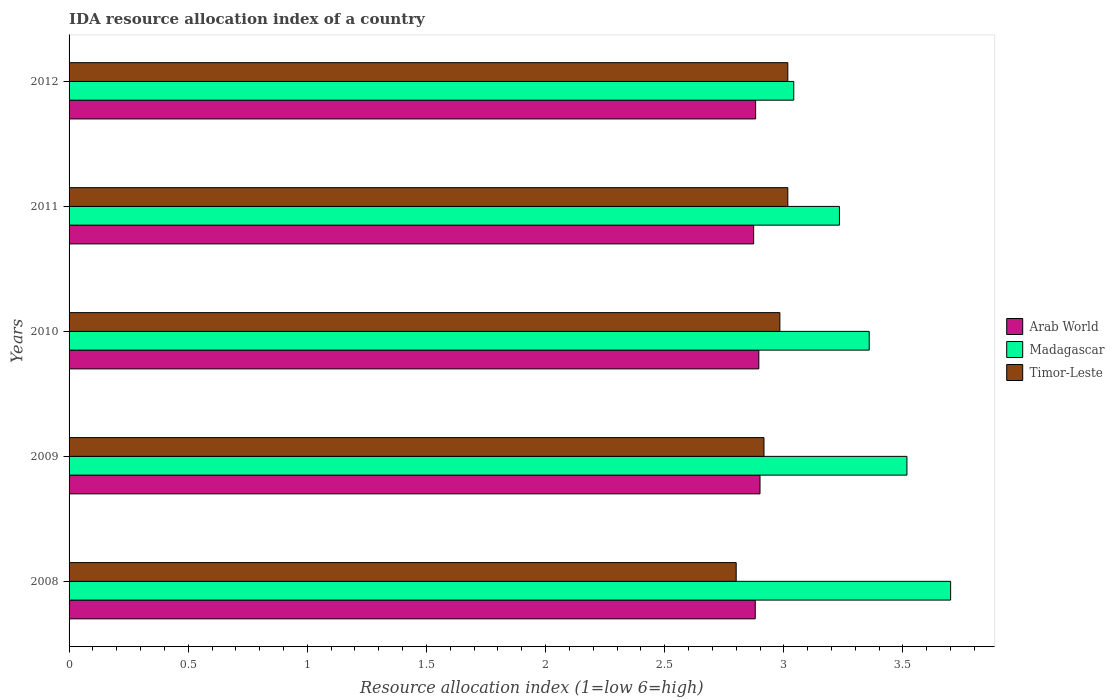Are the number of bars per tick equal to the number of legend labels?
Ensure brevity in your answer.  Yes. How many bars are there on the 3rd tick from the bottom?
Your response must be concise. 3. What is the label of the 1st group of bars from the top?
Keep it short and to the point. 2012. In how many cases, is the number of bars for a given year not equal to the number of legend labels?
Your answer should be compact. 0. What is the IDA resource allocation index in Madagascar in 2008?
Your answer should be very brief. 3.7. Across all years, what is the maximum IDA resource allocation index in Timor-Leste?
Your response must be concise. 3.02. Across all years, what is the minimum IDA resource allocation index in Madagascar?
Offer a terse response. 3.04. In which year was the IDA resource allocation index in Arab World maximum?
Provide a short and direct response. 2009. What is the total IDA resource allocation index in Arab World in the graph?
Make the answer very short. 14.43. What is the difference between the IDA resource allocation index in Arab World in 2009 and that in 2010?
Give a very brief answer. 0. What is the difference between the IDA resource allocation index in Arab World in 2011 and the IDA resource allocation index in Timor-Leste in 2012?
Provide a short and direct response. -0.14. What is the average IDA resource allocation index in Arab World per year?
Your answer should be very brief. 2.89. In the year 2008, what is the difference between the IDA resource allocation index in Timor-Leste and IDA resource allocation index in Madagascar?
Offer a very short reply. -0.9. What is the ratio of the IDA resource allocation index in Madagascar in 2009 to that in 2011?
Make the answer very short. 1.09. Is the IDA resource allocation index in Madagascar in 2008 less than that in 2010?
Your answer should be compact. No. Is the difference between the IDA resource allocation index in Timor-Leste in 2010 and 2012 greater than the difference between the IDA resource allocation index in Madagascar in 2010 and 2012?
Provide a short and direct response. No. What is the difference between the highest and the second highest IDA resource allocation index in Madagascar?
Make the answer very short. 0.18. What is the difference between the highest and the lowest IDA resource allocation index in Madagascar?
Provide a short and direct response. 0.66. In how many years, is the IDA resource allocation index in Timor-Leste greater than the average IDA resource allocation index in Timor-Leste taken over all years?
Provide a short and direct response. 3. What does the 2nd bar from the top in 2009 represents?
Your response must be concise. Madagascar. What does the 3rd bar from the bottom in 2008 represents?
Your response must be concise. Timor-Leste. Is it the case that in every year, the sum of the IDA resource allocation index in Arab World and IDA resource allocation index in Timor-Leste is greater than the IDA resource allocation index in Madagascar?
Provide a succinct answer. Yes. How many years are there in the graph?
Your answer should be very brief. 5. Does the graph contain any zero values?
Your answer should be very brief. No. Does the graph contain grids?
Your answer should be very brief. No. Where does the legend appear in the graph?
Provide a short and direct response. Center right. How many legend labels are there?
Give a very brief answer. 3. What is the title of the graph?
Offer a very short reply. IDA resource allocation index of a country. What is the label or title of the X-axis?
Offer a terse response. Resource allocation index (1=low 6=high). What is the label or title of the Y-axis?
Your answer should be very brief. Years. What is the Resource allocation index (1=low 6=high) in Arab World in 2008?
Make the answer very short. 2.88. What is the Resource allocation index (1=low 6=high) in Timor-Leste in 2008?
Your answer should be compact. 2.8. What is the Resource allocation index (1=low 6=high) in Madagascar in 2009?
Offer a very short reply. 3.52. What is the Resource allocation index (1=low 6=high) of Timor-Leste in 2009?
Offer a terse response. 2.92. What is the Resource allocation index (1=low 6=high) of Arab World in 2010?
Your response must be concise. 2.9. What is the Resource allocation index (1=low 6=high) of Madagascar in 2010?
Make the answer very short. 3.36. What is the Resource allocation index (1=low 6=high) in Timor-Leste in 2010?
Your answer should be compact. 2.98. What is the Resource allocation index (1=low 6=high) in Arab World in 2011?
Your answer should be compact. 2.87. What is the Resource allocation index (1=low 6=high) of Madagascar in 2011?
Your response must be concise. 3.23. What is the Resource allocation index (1=low 6=high) of Timor-Leste in 2011?
Make the answer very short. 3.02. What is the Resource allocation index (1=low 6=high) of Arab World in 2012?
Your response must be concise. 2.88. What is the Resource allocation index (1=low 6=high) of Madagascar in 2012?
Ensure brevity in your answer.  3.04. What is the Resource allocation index (1=low 6=high) of Timor-Leste in 2012?
Provide a succinct answer. 3.02. Across all years, what is the maximum Resource allocation index (1=low 6=high) of Madagascar?
Your answer should be very brief. 3.7. Across all years, what is the maximum Resource allocation index (1=low 6=high) in Timor-Leste?
Ensure brevity in your answer.  3.02. Across all years, what is the minimum Resource allocation index (1=low 6=high) in Arab World?
Offer a terse response. 2.87. Across all years, what is the minimum Resource allocation index (1=low 6=high) of Madagascar?
Offer a terse response. 3.04. What is the total Resource allocation index (1=low 6=high) in Arab World in the graph?
Offer a terse response. 14.43. What is the total Resource allocation index (1=low 6=high) of Madagascar in the graph?
Offer a very short reply. 16.85. What is the total Resource allocation index (1=low 6=high) in Timor-Leste in the graph?
Make the answer very short. 14.73. What is the difference between the Resource allocation index (1=low 6=high) in Arab World in 2008 and that in 2009?
Your response must be concise. -0.02. What is the difference between the Resource allocation index (1=low 6=high) of Madagascar in 2008 and that in 2009?
Your answer should be compact. 0.18. What is the difference between the Resource allocation index (1=low 6=high) of Timor-Leste in 2008 and that in 2009?
Offer a very short reply. -0.12. What is the difference between the Resource allocation index (1=low 6=high) of Arab World in 2008 and that in 2010?
Your response must be concise. -0.01. What is the difference between the Resource allocation index (1=low 6=high) in Madagascar in 2008 and that in 2010?
Your answer should be very brief. 0.34. What is the difference between the Resource allocation index (1=low 6=high) in Timor-Leste in 2008 and that in 2010?
Provide a succinct answer. -0.18. What is the difference between the Resource allocation index (1=low 6=high) in Arab World in 2008 and that in 2011?
Make the answer very short. 0.01. What is the difference between the Resource allocation index (1=low 6=high) in Madagascar in 2008 and that in 2011?
Provide a succinct answer. 0.47. What is the difference between the Resource allocation index (1=low 6=high) in Timor-Leste in 2008 and that in 2011?
Offer a terse response. -0.22. What is the difference between the Resource allocation index (1=low 6=high) of Arab World in 2008 and that in 2012?
Ensure brevity in your answer.  -0. What is the difference between the Resource allocation index (1=low 6=high) in Madagascar in 2008 and that in 2012?
Your answer should be very brief. 0.66. What is the difference between the Resource allocation index (1=low 6=high) of Timor-Leste in 2008 and that in 2012?
Provide a short and direct response. -0.22. What is the difference between the Resource allocation index (1=low 6=high) in Arab World in 2009 and that in 2010?
Make the answer very short. 0.01. What is the difference between the Resource allocation index (1=low 6=high) in Madagascar in 2009 and that in 2010?
Your response must be concise. 0.16. What is the difference between the Resource allocation index (1=low 6=high) of Timor-Leste in 2009 and that in 2010?
Keep it short and to the point. -0.07. What is the difference between the Resource allocation index (1=low 6=high) of Arab World in 2009 and that in 2011?
Provide a succinct answer. 0.03. What is the difference between the Resource allocation index (1=low 6=high) in Madagascar in 2009 and that in 2011?
Your answer should be very brief. 0.28. What is the difference between the Resource allocation index (1=low 6=high) of Arab World in 2009 and that in 2012?
Your response must be concise. 0.02. What is the difference between the Resource allocation index (1=low 6=high) in Madagascar in 2009 and that in 2012?
Your answer should be compact. 0.47. What is the difference between the Resource allocation index (1=low 6=high) of Timor-Leste in 2009 and that in 2012?
Your answer should be very brief. -0.1. What is the difference between the Resource allocation index (1=low 6=high) in Arab World in 2010 and that in 2011?
Offer a terse response. 0.02. What is the difference between the Resource allocation index (1=low 6=high) of Madagascar in 2010 and that in 2011?
Ensure brevity in your answer.  0.12. What is the difference between the Resource allocation index (1=low 6=high) of Timor-Leste in 2010 and that in 2011?
Ensure brevity in your answer.  -0.03. What is the difference between the Resource allocation index (1=low 6=high) in Arab World in 2010 and that in 2012?
Your response must be concise. 0.01. What is the difference between the Resource allocation index (1=low 6=high) in Madagascar in 2010 and that in 2012?
Keep it short and to the point. 0.32. What is the difference between the Resource allocation index (1=low 6=high) in Timor-Leste in 2010 and that in 2012?
Ensure brevity in your answer.  -0.03. What is the difference between the Resource allocation index (1=low 6=high) in Arab World in 2011 and that in 2012?
Your answer should be compact. -0.01. What is the difference between the Resource allocation index (1=low 6=high) in Madagascar in 2011 and that in 2012?
Provide a short and direct response. 0.19. What is the difference between the Resource allocation index (1=low 6=high) in Timor-Leste in 2011 and that in 2012?
Offer a terse response. 0. What is the difference between the Resource allocation index (1=low 6=high) of Arab World in 2008 and the Resource allocation index (1=low 6=high) of Madagascar in 2009?
Make the answer very short. -0.64. What is the difference between the Resource allocation index (1=low 6=high) of Arab World in 2008 and the Resource allocation index (1=low 6=high) of Timor-Leste in 2009?
Your response must be concise. -0.04. What is the difference between the Resource allocation index (1=low 6=high) in Madagascar in 2008 and the Resource allocation index (1=low 6=high) in Timor-Leste in 2009?
Ensure brevity in your answer.  0.78. What is the difference between the Resource allocation index (1=low 6=high) of Arab World in 2008 and the Resource allocation index (1=low 6=high) of Madagascar in 2010?
Provide a succinct answer. -0.48. What is the difference between the Resource allocation index (1=low 6=high) of Arab World in 2008 and the Resource allocation index (1=low 6=high) of Timor-Leste in 2010?
Provide a succinct answer. -0.1. What is the difference between the Resource allocation index (1=low 6=high) in Madagascar in 2008 and the Resource allocation index (1=low 6=high) in Timor-Leste in 2010?
Offer a terse response. 0.72. What is the difference between the Resource allocation index (1=low 6=high) of Arab World in 2008 and the Resource allocation index (1=low 6=high) of Madagascar in 2011?
Your response must be concise. -0.35. What is the difference between the Resource allocation index (1=low 6=high) of Arab World in 2008 and the Resource allocation index (1=low 6=high) of Timor-Leste in 2011?
Make the answer very short. -0.14. What is the difference between the Resource allocation index (1=low 6=high) of Madagascar in 2008 and the Resource allocation index (1=low 6=high) of Timor-Leste in 2011?
Provide a succinct answer. 0.68. What is the difference between the Resource allocation index (1=low 6=high) in Arab World in 2008 and the Resource allocation index (1=low 6=high) in Madagascar in 2012?
Offer a terse response. -0.16. What is the difference between the Resource allocation index (1=low 6=high) in Arab World in 2008 and the Resource allocation index (1=low 6=high) in Timor-Leste in 2012?
Your answer should be compact. -0.14. What is the difference between the Resource allocation index (1=low 6=high) of Madagascar in 2008 and the Resource allocation index (1=low 6=high) of Timor-Leste in 2012?
Offer a very short reply. 0.68. What is the difference between the Resource allocation index (1=low 6=high) in Arab World in 2009 and the Resource allocation index (1=low 6=high) in Madagascar in 2010?
Ensure brevity in your answer.  -0.46. What is the difference between the Resource allocation index (1=low 6=high) of Arab World in 2009 and the Resource allocation index (1=low 6=high) of Timor-Leste in 2010?
Your response must be concise. -0.08. What is the difference between the Resource allocation index (1=low 6=high) in Madagascar in 2009 and the Resource allocation index (1=low 6=high) in Timor-Leste in 2010?
Your answer should be compact. 0.53. What is the difference between the Resource allocation index (1=low 6=high) in Arab World in 2009 and the Resource allocation index (1=low 6=high) in Madagascar in 2011?
Offer a very short reply. -0.33. What is the difference between the Resource allocation index (1=low 6=high) of Arab World in 2009 and the Resource allocation index (1=low 6=high) of Timor-Leste in 2011?
Give a very brief answer. -0.12. What is the difference between the Resource allocation index (1=low 6=high) in Arab World in 2009 and the Resource allocation index (1=low 6=high) in Madagascar in 2012?
Offer a terse response. -0.14. What is the difference between the Resource allocation index (1=low 6=high) in Arab World in 2009 and the Resource allocation index (1=low 6=high) in Timor-Leste in 2012?
Give a very brief answer. -0.12. What is the difference between the Resource allocation index (1=low 6=high) of Madagascar in 2009 and the Resource allocation index (1=low 6=high) of Timor-Leste in 2012?
Offer a very short reply. 0.5. What is the difference between the Resource allocation index (1=low 6=high) in Arab World in 2010 and the Resource allocation index (1=low 6=high) in Madagascar in 2011?
Your response must be concise. -0.34. What is the difference between the Resource allocation index (1=low 6=high) of Arab World in 2010 and the Resource allocation index (1=low 6=high) of Timor-Leste in 2011?
Your answer should be very brief. -0.12. What is the difference between the Resource allocation index (1=low 6=high) of Madagascar in 2010 and the Resource allocation index (1=low 6=high) of Timor-Leste in 2011?
Give a very brief answer. 0.34. What is the difference between the Resource allocation index (1=low 6=high) of Arab World in 2010 and the Resource allocation index (1=low 6=high) of Madagascar in 2012?
Ensure brevity in your answer.  -0.15. What is the difference between the Resource allocation index (1=low 6=high) of Arab World in 2010 and the Resource allocation index (1=low 6=high) of Timor-Leste in 2012?
Your response must be concise. -0.12. What is the difference between the Resource allocation index (1=low 6=high) of Madagascar in 2010 and the Resource allocation index (1=low 6=high) of Timor-Leste in 2012?
Keep it short and to the point. 0.34. What is the difference between the Resource allocation index (1=low 6=high) in Arab World in 2011 and the Resource allocation index (1=low 6=high) in Madagascar in 2012?
Offer a terse response. -0.17. What is the difference between the Resource allocation index (1=low 6=high) of Arab World in 2011 and the Resource allocation index (1=low 6=high) of Timor-Leste in 2012?
Give a very brief answer. -0.14. What is the difference between the Resource allocation index (1=low 6=high) of Madagascar in 2011 and the Resource allocation index (1=low 6=high) of Timor-Leste in 2012?
Provide a succinct answer. 0.22. What is the average Resource allocation index (1=low 6=high) in Arab World per year?
Make the answer very short. 2.89. What is the average Resource allocation index (1=low 6=high) of Madagascar per year?
Your response must be concise. 3.37. What is the average Resource allocation index (1=low 6=high) of Timor-Leste per year?
Offer a terse response. 2.95. In the year 2008, what is the difference between the Resource allocation index (1=low 6=high) in Arab World and Resource allocation index (1=low 6=high) in Madagascar?
Provide a short and direct response. -0.82. In the year 2009, what is the difference between the Resource allocation index (1=low 6=high) of Arab World and Resource allocation index (1=low 6=high) of Madagascar?
Give a very brief answer. -0.62. In the year 2009, what is the difference between the Resource allocation index (1=low 6=high) in Arab World and Resource allocation index (1=low 6=high) in Timor-Leste?
Ensure brevity in your answer.  -0.02. In the year 2009, what is the difference between the Resource allocation index (1=low 6=high) in Madagascar and Resource allocation index (1=low 6=high) in Timor-Leste?
Ensure brevity in your answer.  0.6. In the year 2010, what is the difference between the Resource allocation index (1=low 6=high) of Arab World and Resource allocation index (1=low 6=high) of Madagascar?
Make the answer very short. -0.46. In the year 2010, what is the difference between the Resource allocation index (1=low 6=high) in Arab World and Resource allocation index (1=low 6=high) in Timor-Leste?
Make the answer very short. -0.09. In the year 2011, what is the difference between the Resource allocation index (1=low 6=high) of Arab World and Resource allocation index (1=low 6=high) of Madagascar?
Keep it short and to the point. -0.36. In the year 2011, what is the difference between the Resource allocation index (1=low 6=high) of Arab World and Resource allocation index (1=low 6=high) of Timor-Leste?
Ensure brevity in your answer.  -0.14. In the year 2011, what is the difference between the Resource allocation index (1=low 6=high) in Madagascar and Resource allocation index (1=low 6=high) in Timor-Leste?
Offer a terse response. 0.22. In the year 2012, what is the difference between the Resource allocation index (1=low 6=high) in Arab World and Resource allocation index (1=low 6=high) in Madagascar?
Keep it short and to the point. -0.16. In the year 2012, what is the difference between the Resource allocation index (1=low 6=high) in Arab World and Resource allocation index (1=low 6=high) in Timor-Leste?
Provide a short and direct response. -0.14. In the year 2012, what is the difference between the Resource allocation index (1=low 6=high) in Madagascar and Resource allocation index (1=low 6=high) in Timor-Leste?
Your answer should be compact. 0.03. What is the ratio of the Resource allocation index (1=low 6=high) in Arab World in 2008 to that in 2009?
Provide a short and direct response. 0.99. What is the ratio of the Resource allocation index (1=low 6=high) of Madagascar in 2008 to that in 2009?
Keep it short and to the point. 1.05. What is the ratio of the Resource allocation index (1=low 6=high) of Timor-Leste in 2008 to that in 2009?
Ensure brevity in your answer.  0.96. What is the ratio of the Resource allocation index (1=low 6=high) in Arab World in 2008 to that in 2010?
Keep it short and to the point. 0.99. What is the ratio of the Resource allocation index (1=low 6=high) in Madagascar in 2008 to that in 2010?
Your answer should be compact. 1.1. What is the ratio of the Resource allocation index (1=low 6=high) of Timor-Leste in 2008 to that in 2010?
Offer a terse response. 0.94. What is the ratio of the Resource allocation index (1=low 6=high) of Madagascar in 2008 to that in 2011?
Provide a short and direct response. 1.14. What is the ratio of the Resource allocation index (1=low 6=high) in Timor-Leste in 2008 to that in 2011?
Provide a succinct answer. 0.93. What is the ratio of the Resource allocation index (1=low 6=high) in Madagascar in 2008 to that in 2012?
Your response must be concise. 1.22. What is the ratio of the Resource allocation index (1=low 6=high) of Timor-Leste in 2008 to that in 2012?
Ensure brevity in your answer.  0.93. What is the ratio of the Resource allocation index (1=low 6=high) of Madagascar in 2009 to that in 2010?
Offer a very short reply. 1.05. What is the ratio of the Resource allocation index (1=low 6=high) in Timor-Leste in 2009 to that in 2010?
Make the answer very short. 0.98. What is the ratio of the Resource allocation index (1=low 6=high) in Arab World in 2009 to that in 2011?
Your answer should be very brief. 1.01. What is the ratio of the Resource allocation index (1=low 6=high) of Madagascar in 2009 to that in 2011?
Your answer should be very brief. 1.09. What is the ratio of the Resource allocation index (1=low 6=high) in Timor-Leste in 2009 to that in 2011?
Your response must be concise. 0.97. What is the ratio of the Resource allocation index (1=low 6=high) in Arab World in 2009 to that in 2012?
Ensure brevity in your answer.  1.01. What is the ratio of the Resource allocation index (1=low 6=high) in Madagascar in 2009 to that in 2012?
Your answer should be compact. 1.16. What is the ratio of the Resource allocation index (1=low 6=high) in Timor-Leste in 2009 to that in 2012?
Keep it short and to the point. 0.97. What is the ratio of the Resource allocation index (1=low 6=high) in Arab World in 2010 to that in 2011?
Offer a terse response. 1.01. What is the ratio of the Resource allocation index (1=low 6=high) of Madagascar in 2010 to that in 2011?
Offer a very short reply. 1.04. What is the ratio of the Resource allocation index (1=low 6=high) of Arab World in 2010 to that in 2012?
Your answer should be compact. 1. What is the ratio of the Resource allocation index (1=low 6=high) in Madagascar in 2010 to that in 2012?
Offer a very short reply. 1.1. What is the ratio of the Resource allocation index (1=low 6=high) in Madagascar in 2011 to that in 2012?
Offer a very short reply. 1.06. What is the ratio of the Resource allocation index (1=low 6=high) of Timor-Leste in 2011 to that in 2012?
Your answer should be compact. 1. What is the difference between the highest and the second highest Resource allocation index (1=low 6=high) of Arab World?
Your answer should be very brief. 0.01. What is the difference between the highest and the second highest Resource allocation index (1=low 6=high) of Madagascar?
Your answer should be very brief. 0.18. What is the difference between the highest and the lowest Resource allocation index (1=low 6=high) of Arab World?
Offer a terse response. 0.03. What is the difference between the highest and the lowest Resource allocation index (1=low 6=high) in Madagascar?
Keep it short and to the point. 0.66. What is the difference between the highest and the lowest Resource allocation index (1=low 6=high) in Timor-Leste?
Make the answer very short. 0.22. 